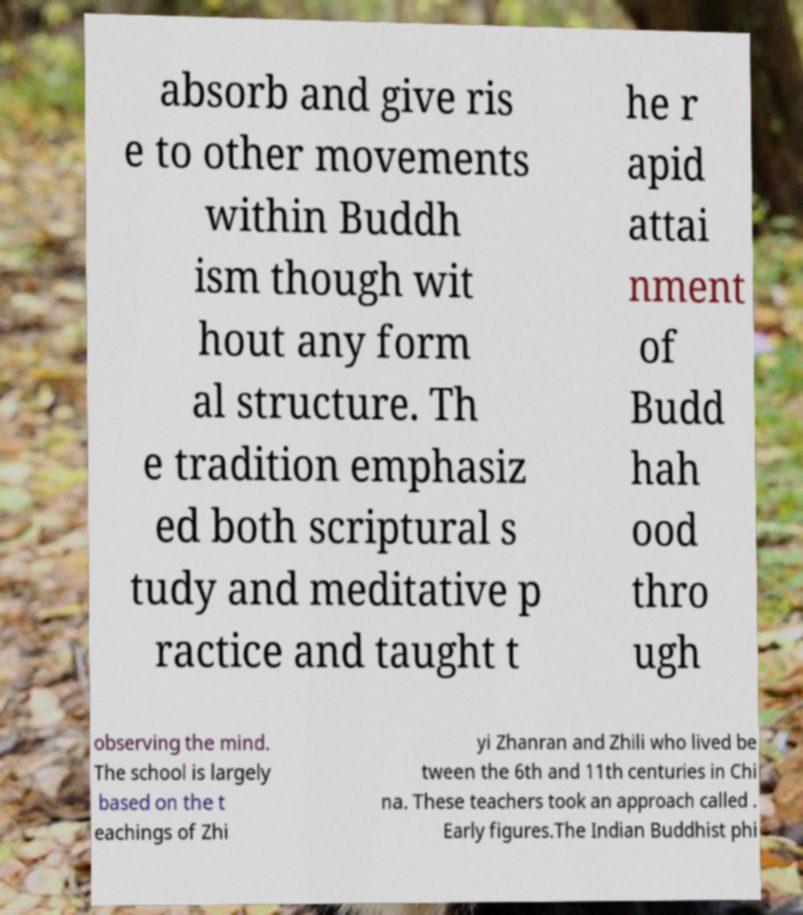There's text embedded in this image that I need extracted. Can you transcribe it verbatim? absorb and give ris e to other movements within Buddh ism though wit hout any form al structure. Th e tradition emphasiz ed both scriptural s tudy and meditative p ractice and taught t he r apid attai nment of Budd hah ood thro ugh observing the mind. The school is largely based on the t eachings of Zhi yi Zhanran and Zhili who lived be tween the 6th and 11th centuries in Chi na. These teachers took an approach called . Early figures.The Indian Buddhist phi 